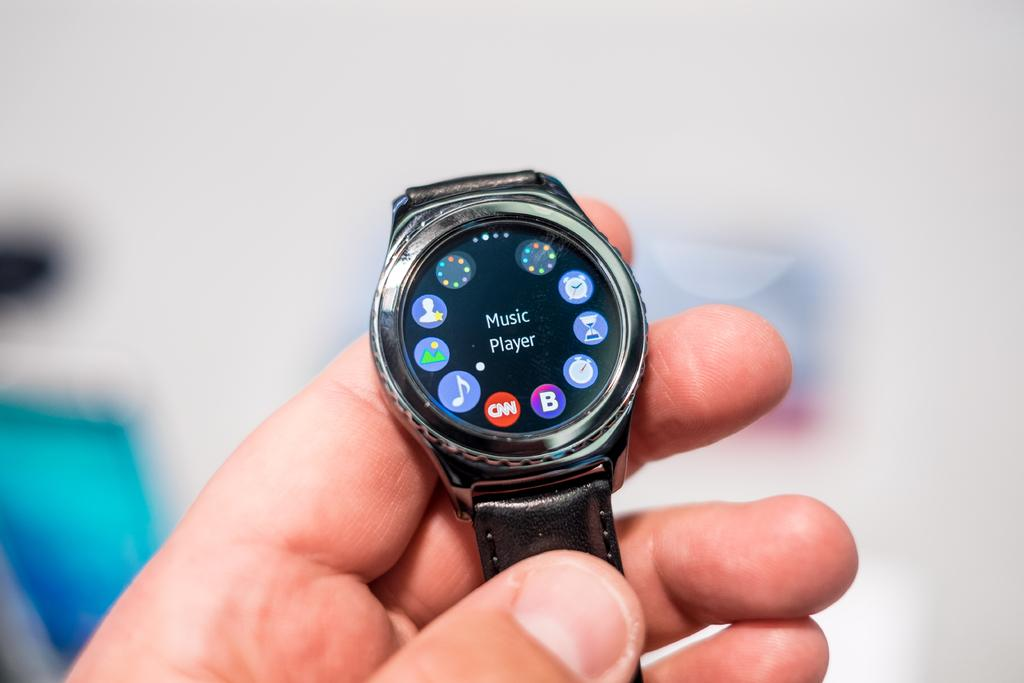<image>
Render a clear and concise summary of the photo. A smart watch with the words Music Player 